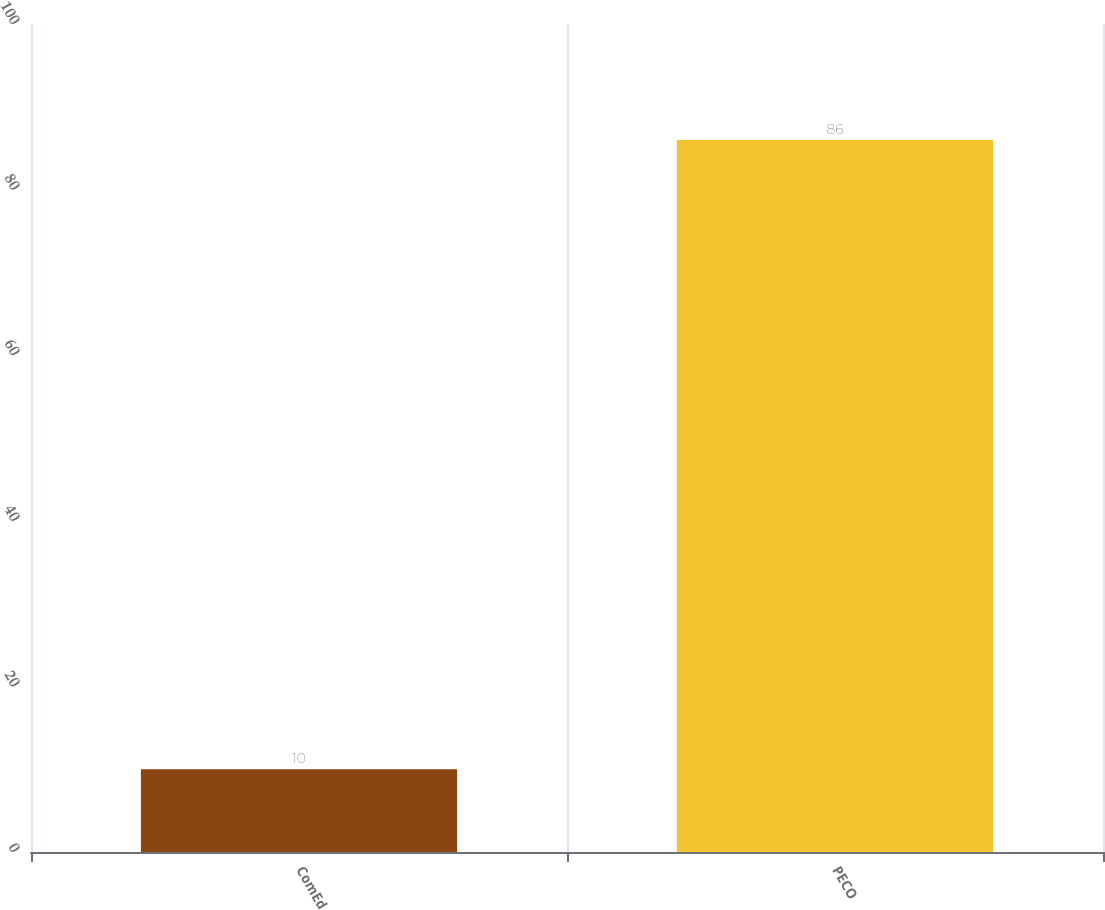Convert chart to OTSL. <chart><loc_0><loc_0><loc_500><loc_500><bar_chart><fcel>ComEd<fcel>PECO<nl><fcel>10<fcel>86<nl></chart> 